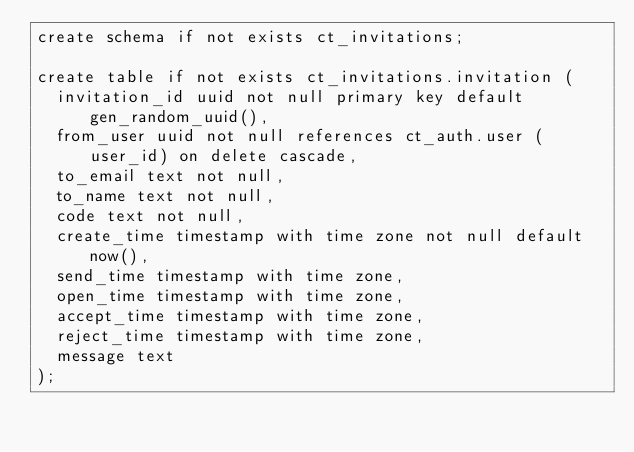<code> <loc_0><loc_0><loc_500><loc_500><_SQL_>create schema if not exists ct_invitations;

create table if not exists ct_invitations.invitation (
  invitation_id uuid not null primary key default gen_random_uuid(),
  from_user uuid not null references ct_auth.user (user_id) on delete cascade,
  to_email text not null,
  to_name text not null,
  code text not null,
  create_time timestamp with time zone not null default now(),
  send_time timestamp with time zone,
  open_time timestamp with time zone,
  accept_time timestamp with time zone,
  reject_time timestamp with time zone,
  message text
);
</code> 